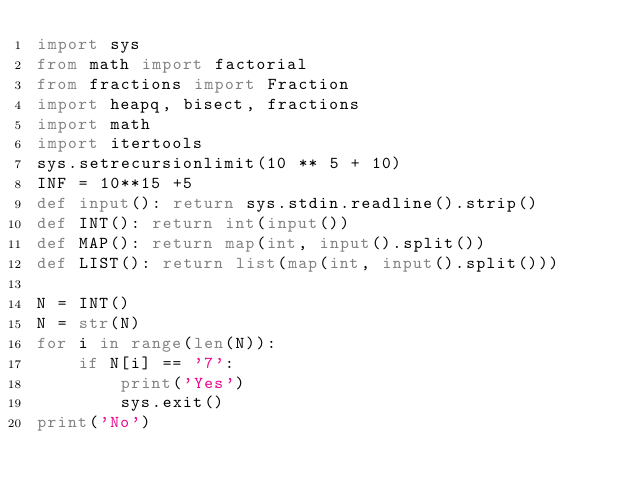Convert code to text. <code><loc_0><loc_0><loc_500><loc_500><_Python_>import sys
from math import factorial
from fractions import Fraction
import heapq, bisect, fractions
import math
import itertools
sys.setrecursionlimit(10 ** 5 + 10)
INF = 10**15 +5
def input(): return sys.stdin.readline().strip()
def INT(): return int(input())
def MAP(): return map(int, input().split())
def LIST(): return list(map(int, input().split()))

N = INT()
N = str(N)
for i in range(len(N)):
    if N[i] == '7':
        print('Yes')
        sys.exit()
print('No')</code> 